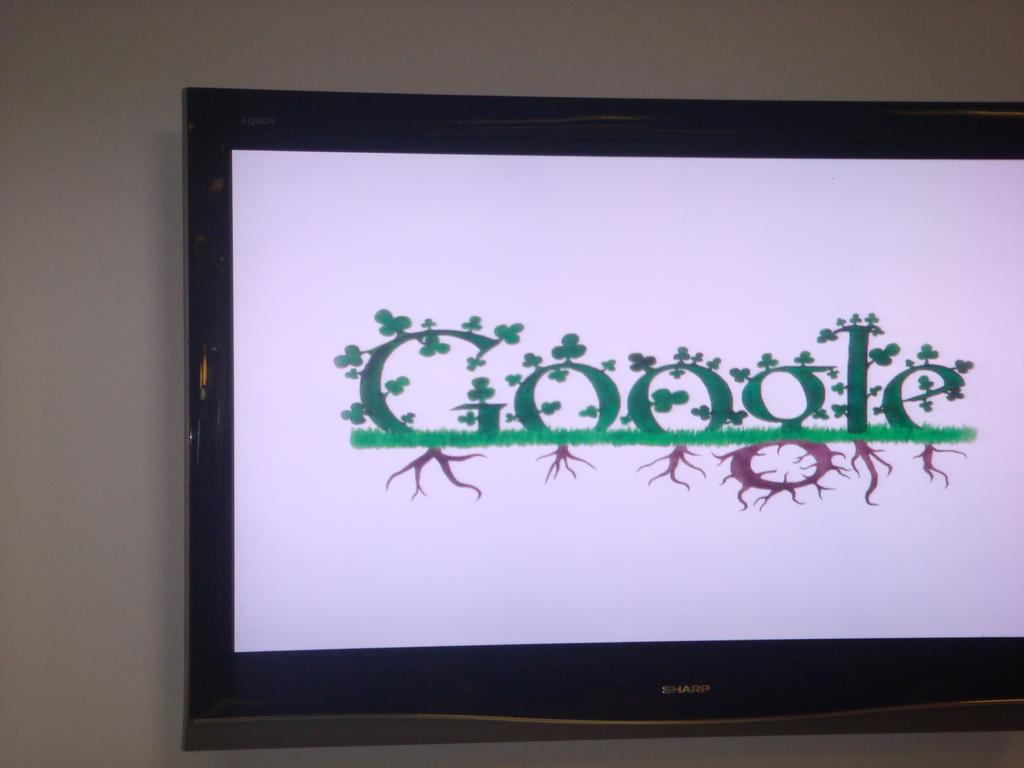<image>
Give a short and clear explanation of the subsequent image. The Google home screen sits on a screen on the wall. 